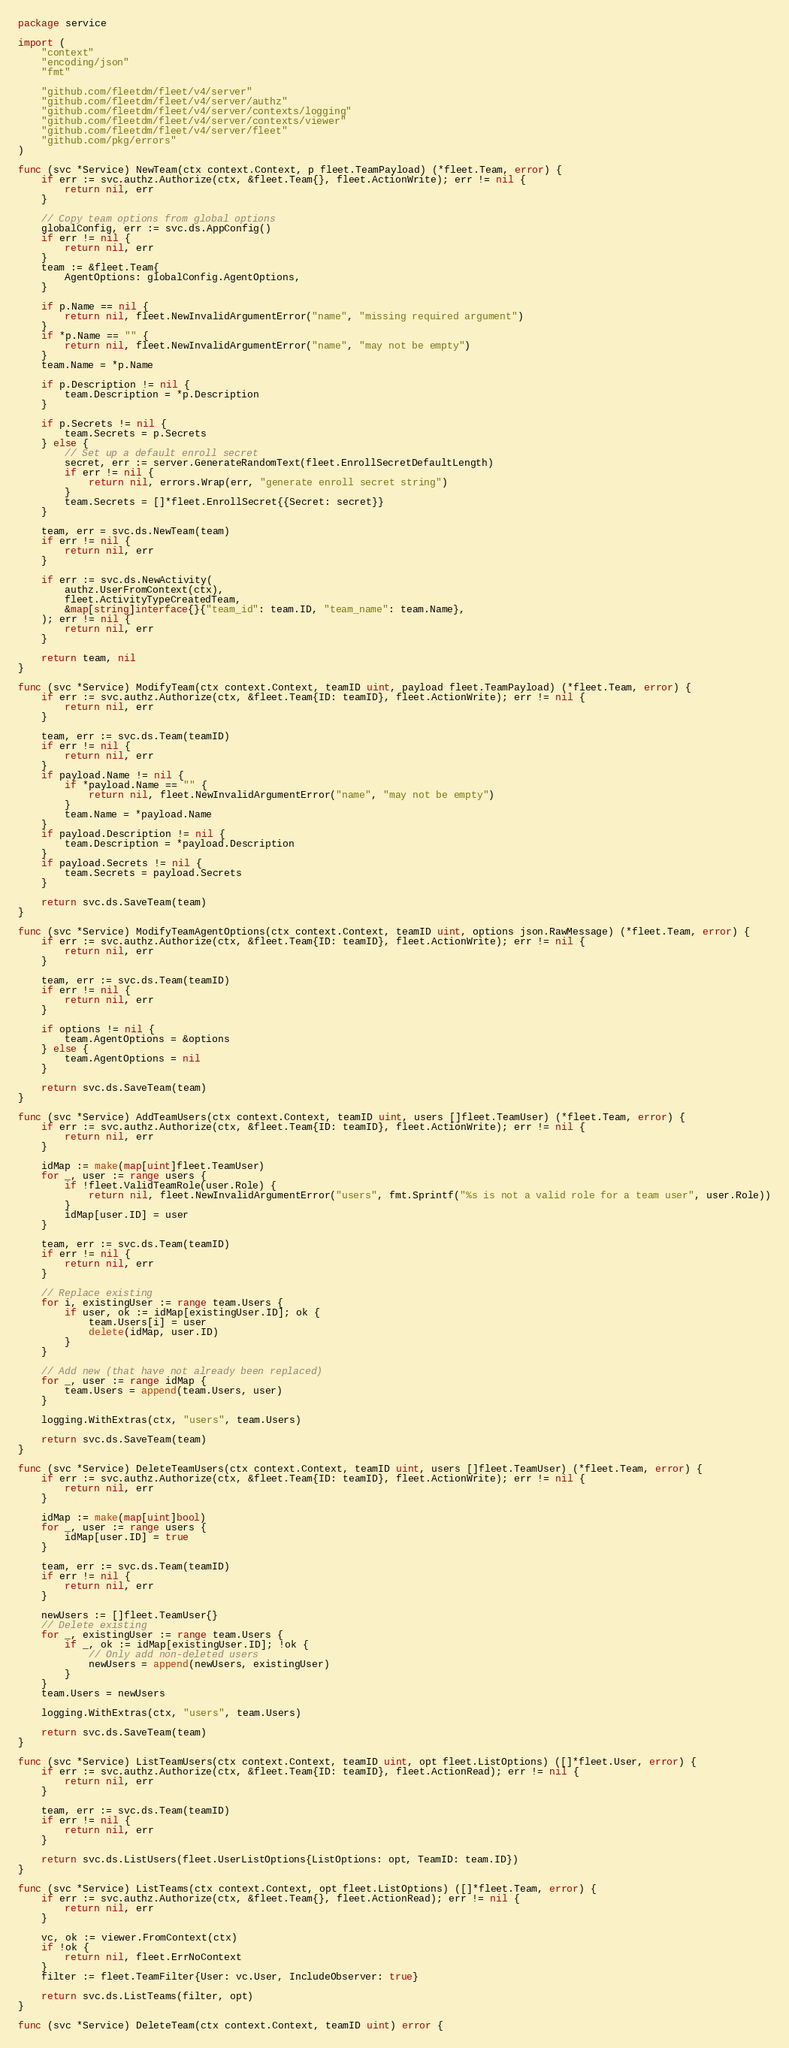Convert code to text. <code><loc_0><loc_0><loc_500><loc_500><_Go_>package service

import (
	"context"
	"encoding/json"
	"fmt"

	"github.com/fleetdm/fleet/v4/server"
	"github.com/fleetdm/fleet/v4/server/authz"
	"github.com/fleetdm/fleet/v4/server/contexts/logging"
	"github.com/fleetdm/fleet/v4/server/contexts/viewer"
	"github.com/fleetdm/fleet/v4/server/fleet"
	"github.com/pkg/errors"
)

func (svc *Service) NewTeam(ctx context.Context, p fleet.TeamPayload) (*fleet.Team, error) {
	if err := svc.authz.Authorize(ctx, &fleet.Team{}, fleet.ActionWrite); err != nil {
		return nil, err
	}

	// Copy team options from global options
	globalConfig, err := svc.ds.AppConfig()
	if err != nil {
		return nil, err
	}
	team := &fleet.Team{
		AgentOptions: globalConfig.AgentOptions,
	}

	if p.Name == nil {
		return nil, fleet.NewInvalidArgumentError("name", "missing required argument")
	}
	if *p.Name == "" {
		return nil, fleet.NewInvalidArgumentError("name", "may not be empty")
	}
	team.Name = *p.Name

	if p.Description != nil {
		team.Description = *p.Description
	}

	if p.Secrets != nil {
		team.Secrets = p.Secrets
	} else {
		// Set up a default enroll secret
		secret, err := server.GenerateRandomText(fleet.EnrollSecretDefaultLength)
		if err != nil {
			return nil, errors.Wrap(err, "generate enroll secret string")
		}
		team.Secrets = []*fleet.EnrollSecret{{Secret: secret}}
	}

	team, err = svc.ds.NewTeam(team)
	if err != nil {
		return nil, err
	}

	if err := svc.ds.NewActivity(
		authz.UserFromContext(ctx),
		fleet.ActivityTypeCreatedTeam,
		&map[string]interface{}{"team_id": team.ID, "team_name": team.Name},
	); err != nil {
		return nil, err
	}

	return team, nil
}

func (svc *Service) ModifyTeam(ctx context.Context, teamID uint, payload fleet.TeamPayload) (*fleet.Team, error) {
	if err := svc.authz.Authorize(ctx, &fleet.Team{ID: teamID}, fleet.ActionWrite); err != nil {
		return nil, err
	}

	team, err := svc.ds.Team(teamID)
	if err != nil {
		return nil, err
	}
	if payload.Name != nil {
		if *payload.Name == "" {
			return nil, fleet.NewInvalidArgumentError("name", "may not be empty")
		}
		team.Name = *payload.Name
	}
	if payload.Description != nil {
		team.Description = *payload.Description
	}
	if payload.Secrets != nil {
		team.Secrets = payload.Secrets
	}

	return svc.ds.SaveTeam(team)
}

func (svc *Service) ModifyTeamAgentOptions(ctx context.Context, teamID uint, options json.RawMessage) (*fleet.Team, error) {
	if err := svc.authz.Authorize(ctx, &fleet.Team{ID: teamID}, fleet.ActionWrite); err != nil {
		return nil, err
	}

	team, err := svc.ds.Team(teamID)
	if err != nil {
		return nil, err
	}

	if options != nil {
		team.AgentOptions = &options
	} else {
		team.AgentOptions = nil
	}

	return svc.ds.SaveTeam(team)
}

func (svc *Service) AddTeamUsers(ctx context.Context, teamID uint, users []fleet.TeamUser) (*fleet.Team, error) {
	if err := svc.authz.Authorize(ctx, &fleet.Team{ID: teamID}, fleet.ActionWrite); err != nil {
		return nil, err
	}

	idMap := make(map[uint]fleet.TeamUser)
	for _, user := range users {
		if !fleet.ValidTeamRole(user.Role) {
			return nil, fleet.NewInvalidArgumentError("users", fmt.Sprintf("%s is not a valid role for a team user", user.Role))
		}
		idMap[user.ID] = user
	}

	team, err := svc.ds.Team(teamID)
	if err != nil {
		return nil, err
	}

	// Replace existing
	for i, existingUser := range team.Users {
		if user, ok := idMap[existingUser.ID]; ok {
			team.Users[i] = user
			delete(idMap, user.ID)
		}
	}

	// Add new (that have not already been replaced)
	for _, user := range idMap {
		team.Users = append(team.Users, user)
	}

	logging.WithExtras(ctx, "users", team.Users)

	return svc.ds.SaveTeam(team)
}

func (svc *Service) DeleteTeamUsers(ctx context.Context, teamID uint, users []fleet.TeamUser) (*fleet.Team, error) {
	if err := svc.authz.Authorize(ctx, &fleet.Team{ID: teamID}, fleet.ActionWrite); err != nil {
		return nil, err
	}

	idMap := make(map[uint]bool)
	for _, user := range users {
		idMap[user.ID] = true
	}

	team, err := svc.ds.Team(teamID)
	if err != nil {
		return nil, err
	}

	newUsers := []fleet.TeamUser{}
	// Delete existing
	for _, existingUser := range team.Users {
		if _, ok := idMap[existingUser.ID]; !ok {
			// Only add non-deleted users
			newUsers = append(newUsers, existingUser)
		}
	}
	team.Users = newUsers

	logging.WithExtras(ctx, "users", team.Users)

	return svc.ds.SaveTeam(team)
}

func (svc *Service) ListTeamUsers(ctx context.Context, teamID uint, opt fleet.ListOptions) ([]*fleet.User, error) {
	if err := svc.authz.Authorize(ctx, &fleet.Team{ID: teamID}, fleet.ActionRead); err != nil {
		return nil, err
	}

	team, err := svc.ds.Team(teamID)
	if err != nil {
		return nil, err
	}

	return svc.ds.ListUsers(fleet.UserListOptions{ListOptions: opt, TeamID: team.ID})
}

func (svc *Service) ListTeams(ctx context.Context, opt fleet.ListOptions) ([]*fleet.Team, error) {
	if err := svc.authz.Authorize(ctx, &fleet.Team{}, fleet.ActionRead); err != nil {
		return nil, err
	}

	vc, ok := viewer.FromContext(ctx)
	if !ok {
		return nil, fleet.ErrNoContext
	}
	filter := fleet.TeamFilter{User: vc.User, IncludeObserver: true}

	return svc.ds.ListTeams(filter, opt)
}

func (svc *Service) DeleteTeam(ctx context.Context, teamID uint) error {</code> 